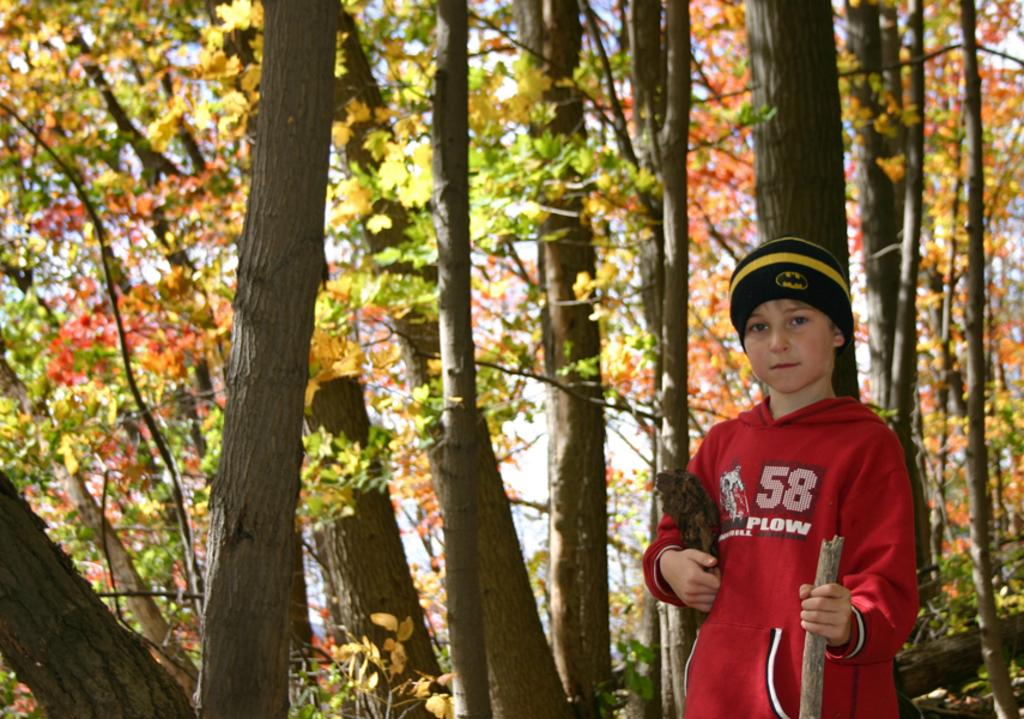Provide a one-sentence caption for the provided image. A boy with 58 Plow on his shirt wears a black and yellow winter hat. 